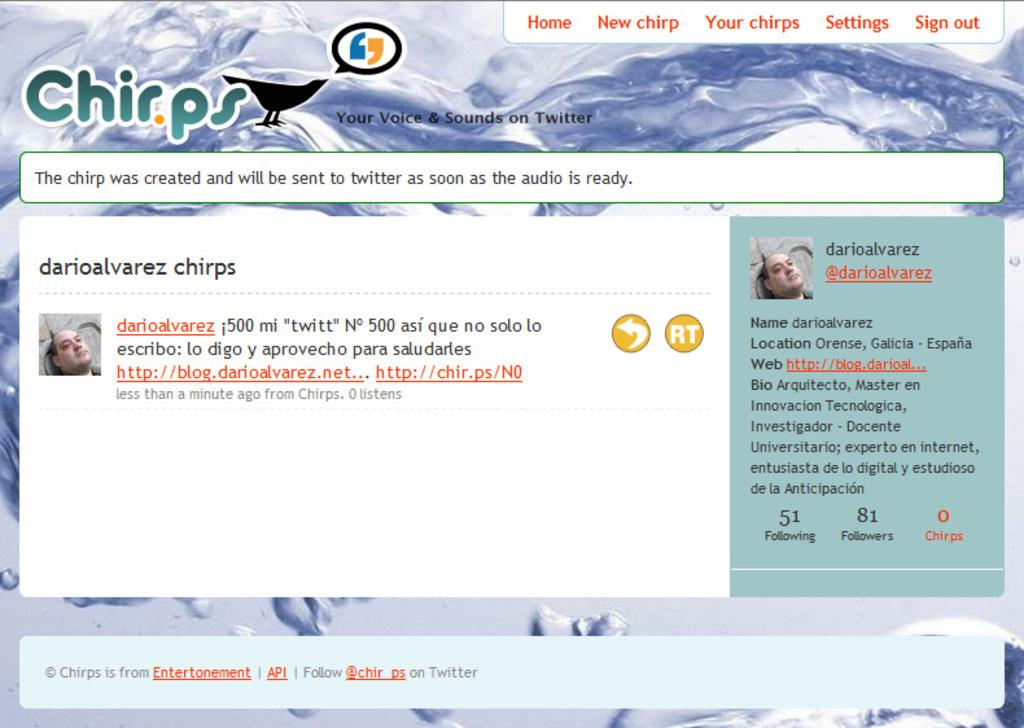What is the main feature of the image? There is a screen in the image. What can be seen on the screen? The screen contains text and images. How does the screen appear in the image? The screen resembles a web page. How does the window in the image twist to reveal a hidden message? There is no window present in the image, and therefore no twisting or hidden message can be observed. 